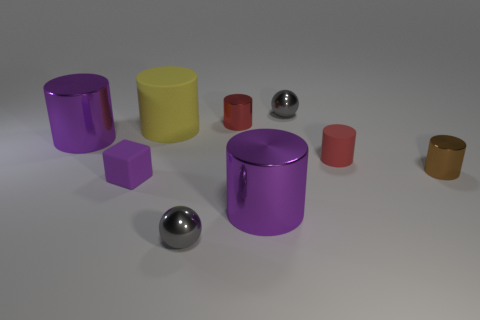Subtract all purple cylinders. How many cylinders are left? 4 Subtract all yellow cylinders. How many cylinders are left? 5 Subtract all cyan cylinders. Subtract all cyan spheres. How many cylinders are left? 6 Add 1 large red metal cylinders. How many objects exist? 10 Subtract all cubes. How many objects are left? 8 Subtract 0 red spheres. How many objects are left? 9 Subtract all purple rubber blocks. Subtract all big gray cylinders. How many objects are left? 8 Add 5 small purple cubes. How many small purple cubes are left? 6 Add 6 yellow matte objects. How many yellow matte objects exist? 7 